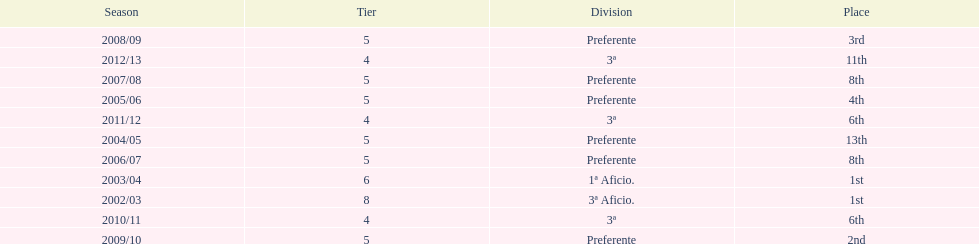Could you parse the entire table? {'header': ['Season', 'Tier', 'Division', 'Place'], 'rows': [['2008/09', '5', 'Preferente', '3rd'], ['2012/13', '4', '3ª', '11th'], ['2007/08', '5', 'Preferente', '8th'], ['2005/06', '5', 'Preferente', '4th'], ['2011/12', '4', '3ª', '6th'], ['2004/05', '5', 'Preferente', '13th'], ['2006/07', '5', 'Preferente', '8th'], ['2003/04', '6', '1ª Aficio.', '1st'], ['2002/03', '8', '3ª Aficio.', '1st'], ['2010/11', '4', '3ª', '6th'], ['2009/10', '5', 'Preferente', '2nd']]} Which division has the largest number of ranks? Preferente. 